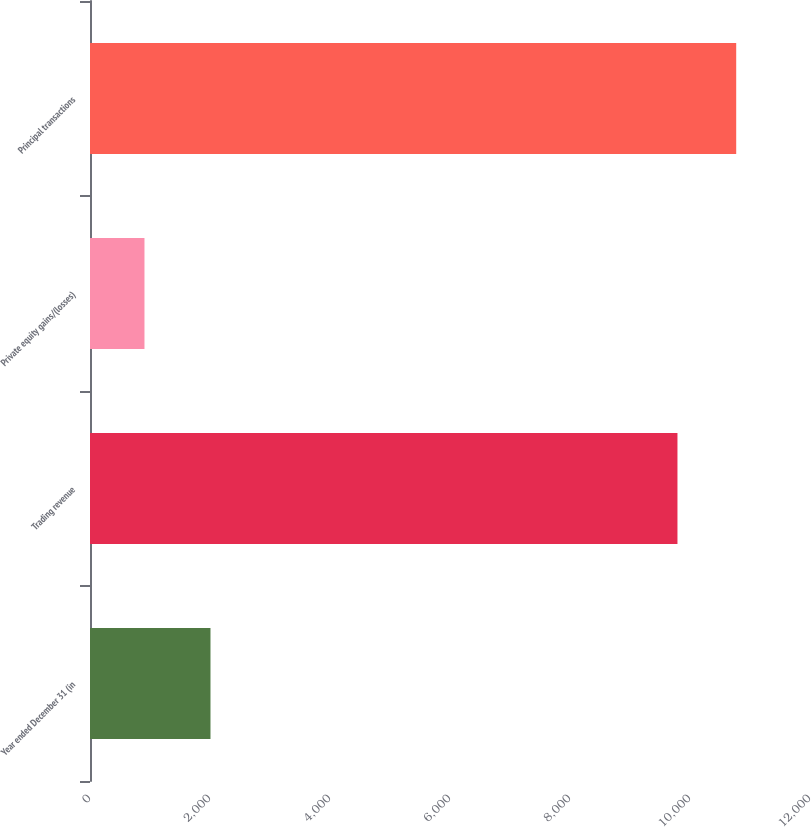Convert chart to OTSL. <chart><loc_0><loc_0><loc_500><loc_500><bar_chart><fcel>Year ended December 31 (in<fcel>Trading revenue<fcel>Private equity gains/(losses)<fcel>Principal transactions<nl><fcel>2008<fcel>9791<fcel>908<fcel>10770.1<nl></chart> 